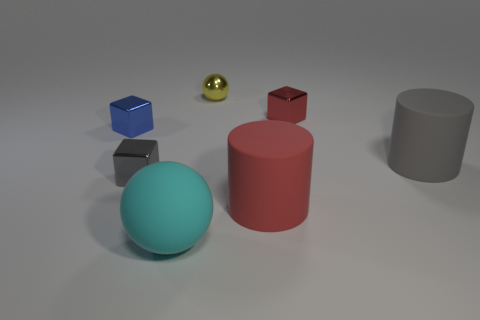Subtract all small gray cubes. How many cubes are left? 2 Add 1 small yellow cylinders. How many objects exist? 8 Subtract all cyan balls. How many balls are left? 1 Subtract 1 cylinders. How many cylinders are left? 1 Subtract all gray objects. Subtract all red rubber things. How many objects are left? 4 Add 7 small gray blocks. How many small gray blocks are left? 8 Add 1 blue rubber blocks. How many blue rubber blocks exist? 1 Subtract 1 cyan balls. How many objects are left? 6 Subtract all cubes. How many objects are left? 4 Subtract all red blocks. Subtract all blue cylinders. How many blocks are left? 2 